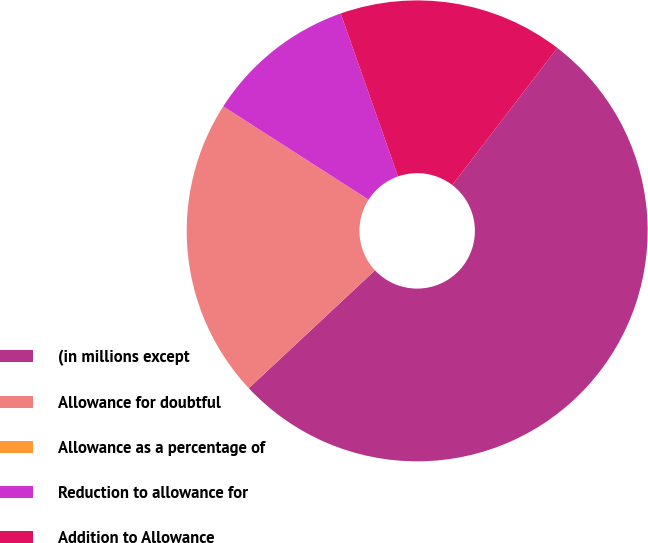Convert chart. <chart><loc_0><loc_0><loc_500><loc_500><pie_chart><fcel>(in millions except<fcel>Allowance for doubtful<fcel>Allowance as a percentage of<fcel>Reduction to allowance for<fcel>Addition to Allowance<nl><fcel>52.63%<fcel>21.05%<fcel>0.0%<fcel>10.53%<fcel>15.79%<nl></chart> 